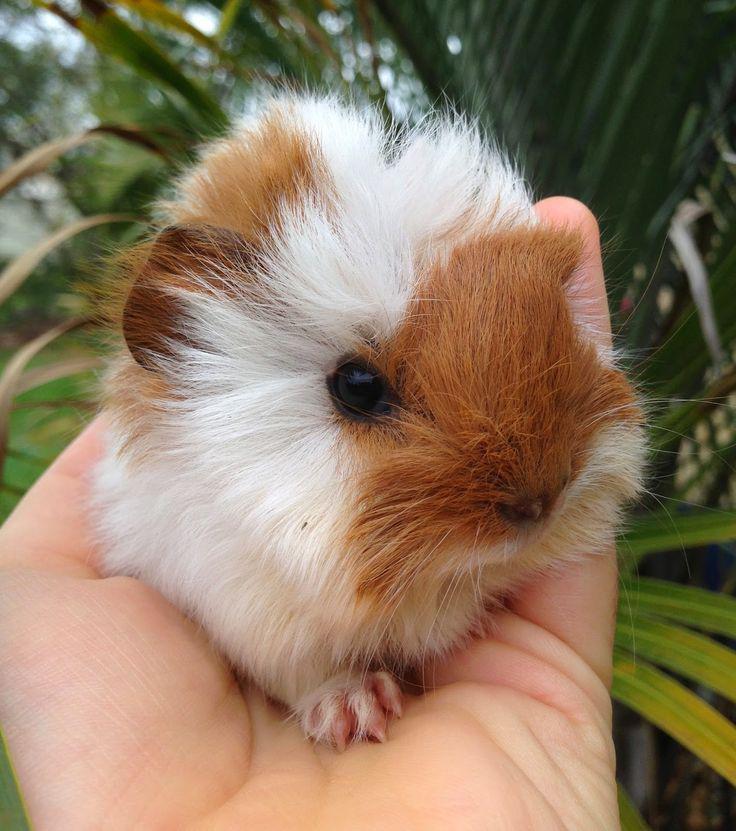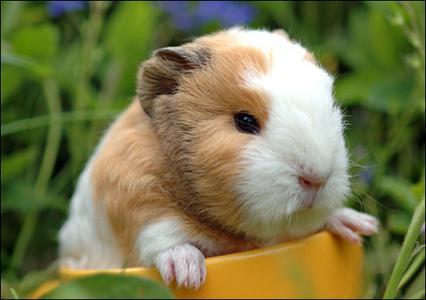The first image is the image on the left, the second image is the image on the right. Evaluate the accuracy of this statement regarding the images: "Each image contains the same number of guinea pigs, and all animals share similar poses.". Is it true? Answer yes or no. Yes. 